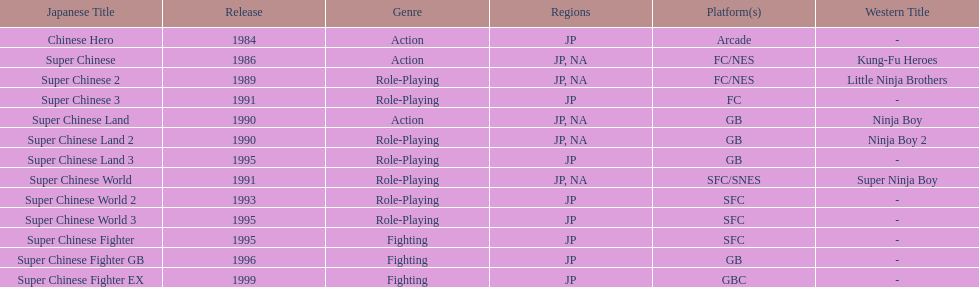Count of super chinese global games launched 3. 